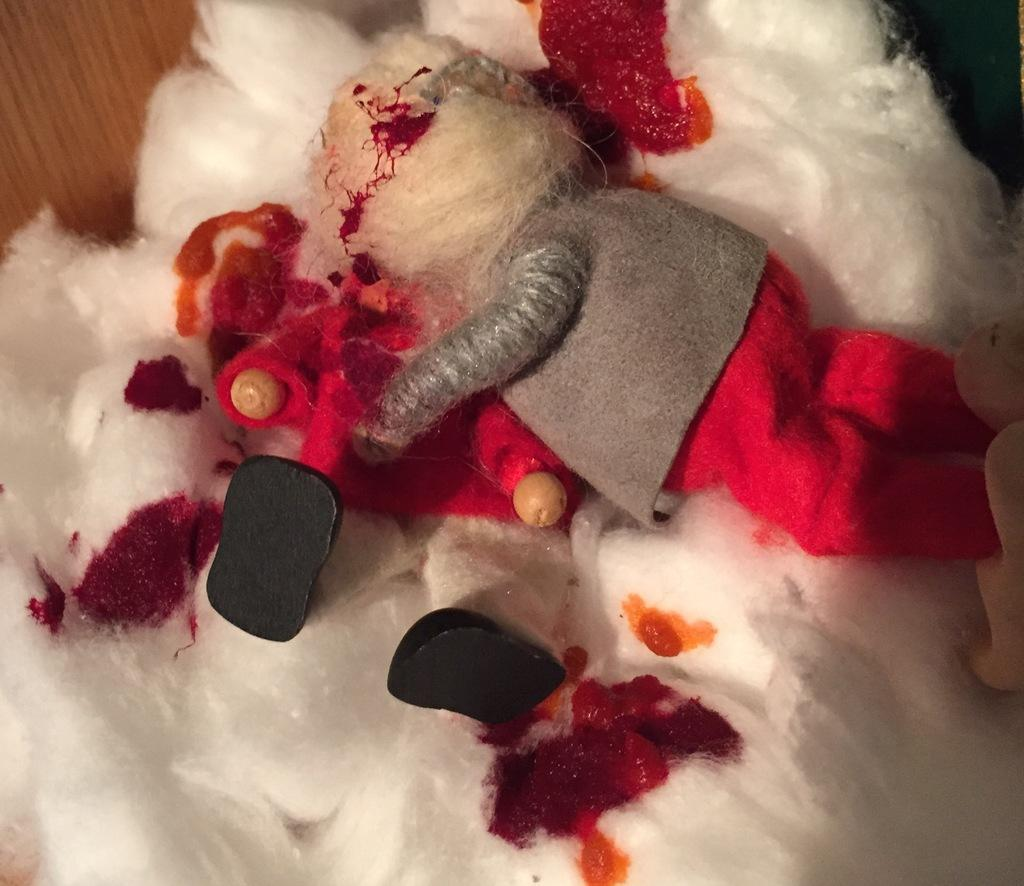What material is the main object in the image made of? The main object in the image is a wooden plank. What is placed on the wooden plank? Cotton is present on the wooden plank. What is sitting on the cotton? There is a doll on the cotton. What can be observed on the cotton besides the doll? There are red color marks on the cotton. What is the doll writing on the cotton with a pin? There is no writing or pin present in the image; the doll is simply sitting on the cotton. 